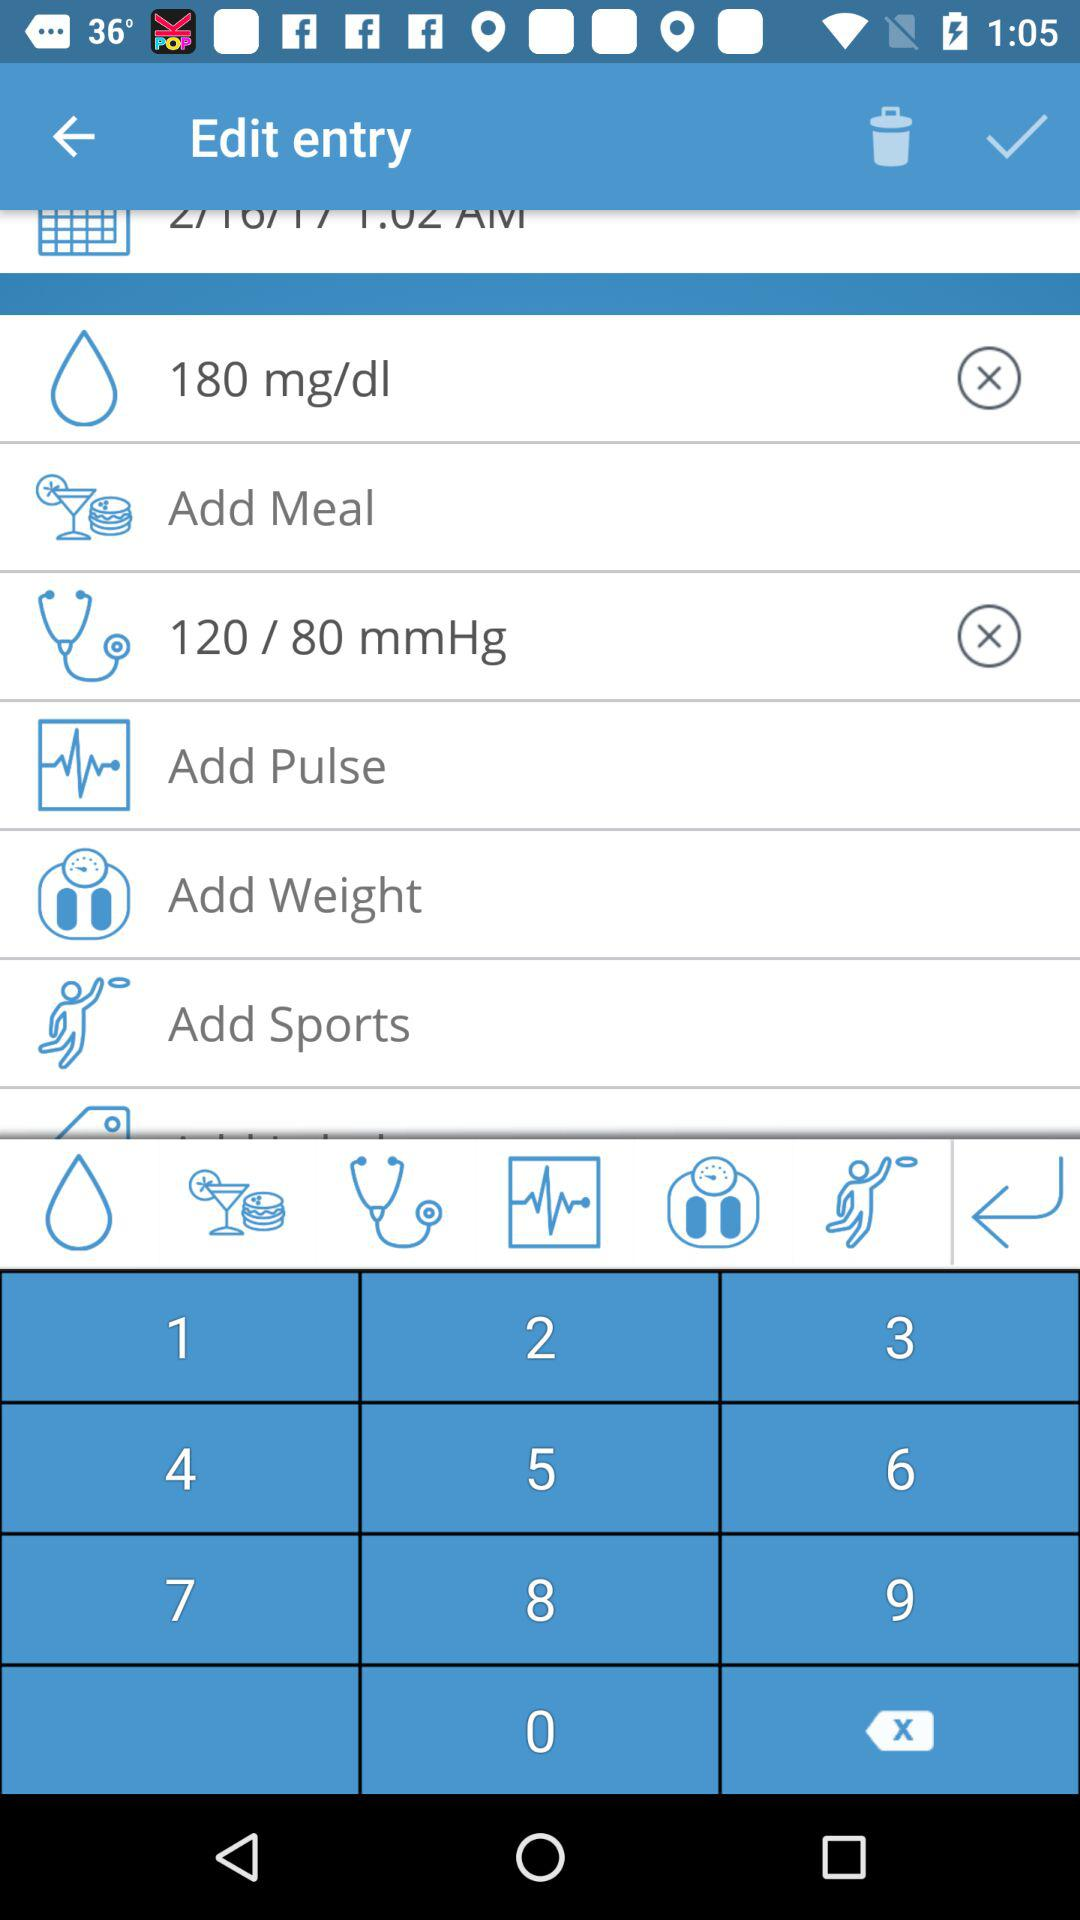Which options are selected? The selected options are "180 mg/dl" and "120 / 80 mmHg". 